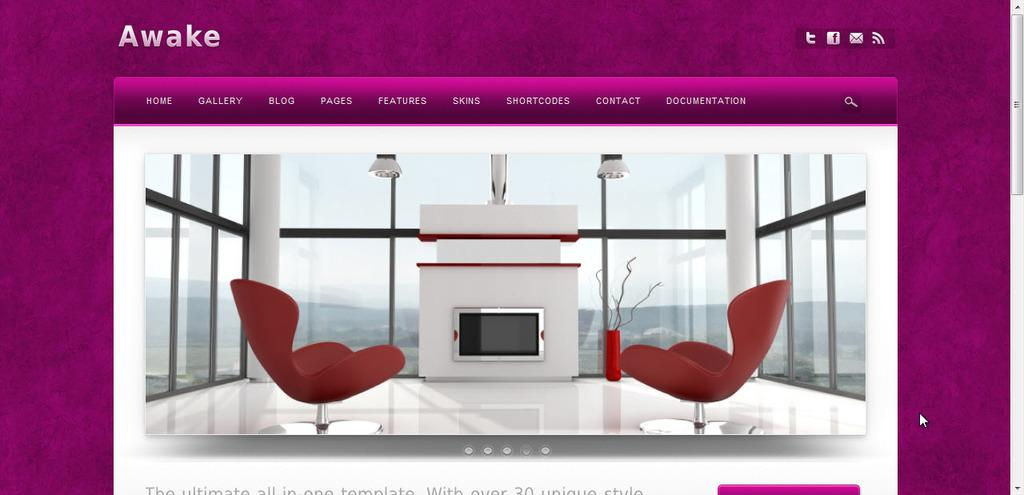<image>
Write a terse but informative summary of the picture. A website page that shows an interior decorating design and the words awake on it 